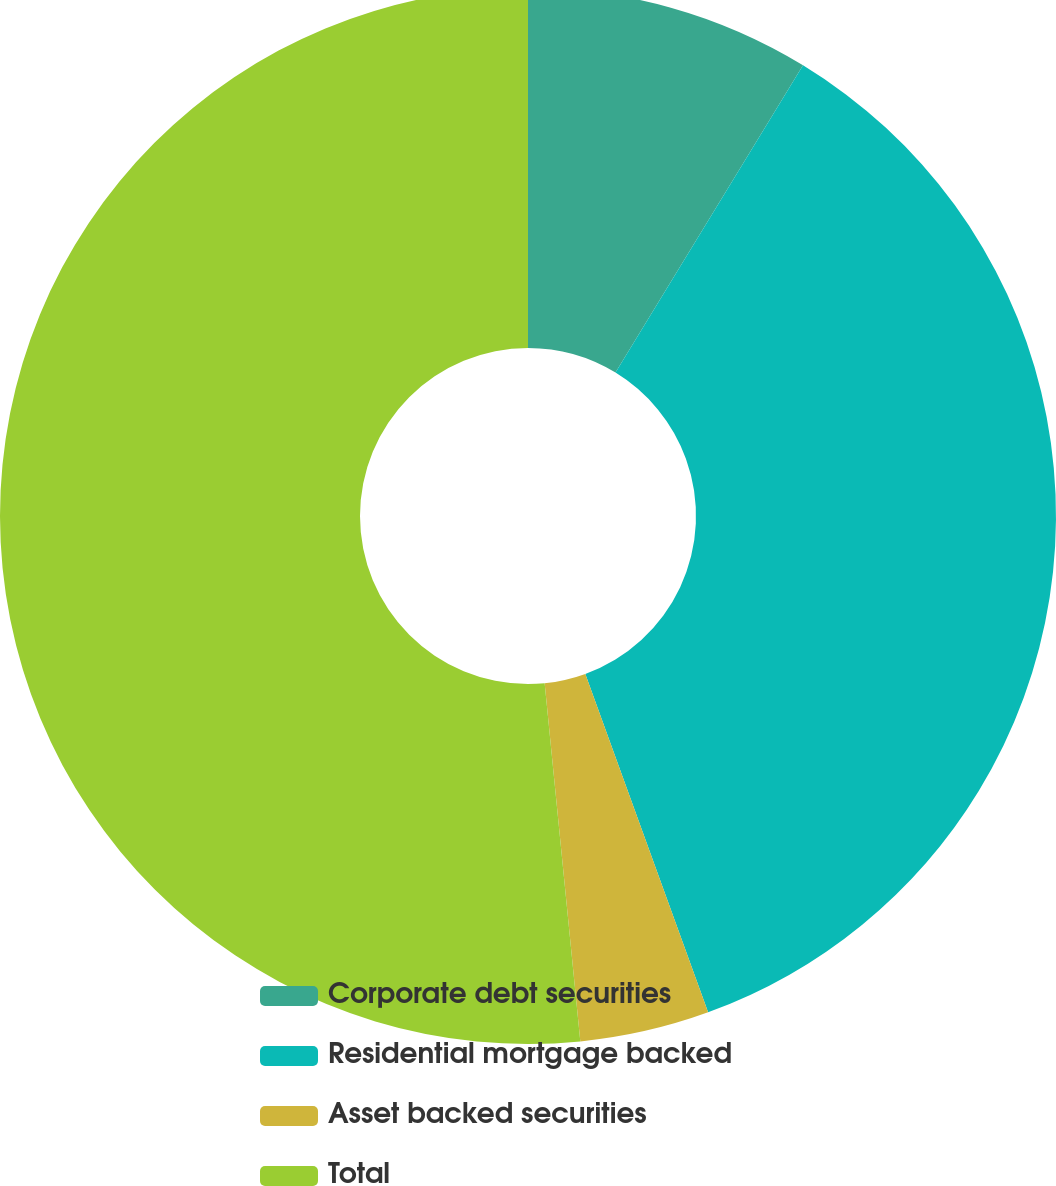Convert chart. <chart><loc_0><loc_0><loc_500><loc_500><pie_chart><fcel>Corporate debt securities<fcel>Residential mortgage backed<fcel>Asset backed securities<fcel>Total<nl><fcel>8.72%<fcel>35.74%<fcel>3.96%<fcel>51.58%<nl></chart> 